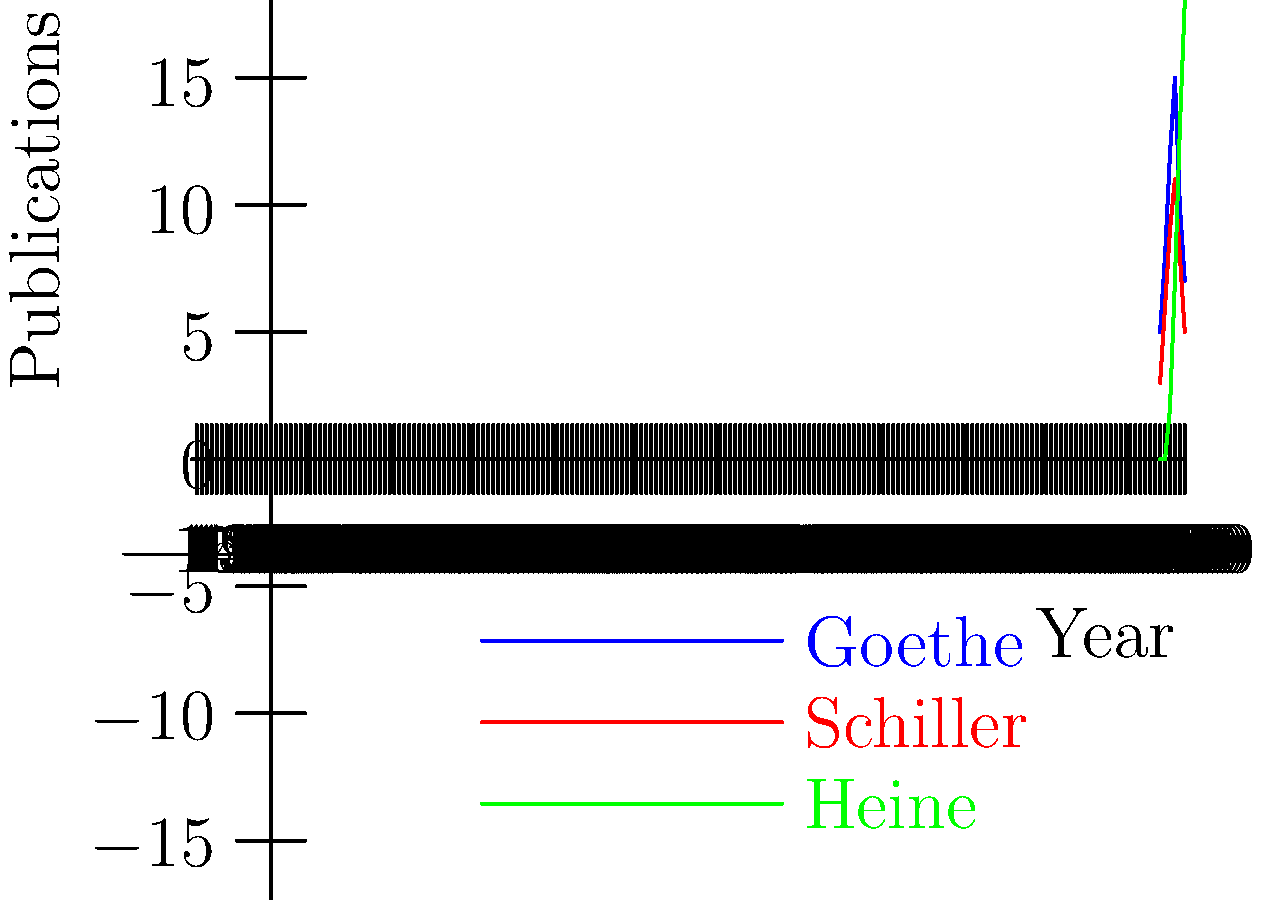Based on the line graph showing the publication frequency of three German poets (Goethe, Schiller, and Heine) from 1800 to 1850, which poet experienced the most significant increase in publications during this period, and what might this suggest about their literary career? To determine which poet experienced the most significant increase in publications, we need to analyze the trends for each poet:

1. Goethe:
   - Started with 5 publications in 1800
   - Peaked at 15 publications in 1830
   - Ended with 7 publications in 1850
   - Overall increase: 2 publications (40% increase)

2. Schiller:
   - Started with 3 publications in 1800
   - Peaked at 11 publications in 1830
   - Ended with 5 publications in 1850
   - Overall increase: 2 publications (66.7% increase)

3. Heine:
   - Started with 0 publications in 1800
   - Consistently increased over time
   - Ended with 18 publications in 1850
   - Overall increase: 18 publications (infinite % increase)

Heine experienced the most significant increase, both in absolute numbers and percentage. This suggests that Heine's literary career took off later than Goethe's and Schiller's but gained momentum rapidly.

This trend might indicate:
1. Heine was likely born later than Goethe and Schiller.
2. Heine's style or themes became increasingly popular over time.
3. Heine's prolific period coincided with changing literary tastes or political climate.

As an archivist specializing in German literary history, this graph provides valuable insights into the trajectories of these poets' careers and their relative influence over time.
Answer: Heinrich Heine experienced the most significant increase, suggesting a late but rapidly ascending literary career. 